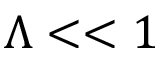Convert formula to latex. <formula><loc_0><loc_0><loc_500><loc_500>\Lambda < < 1</formula> 